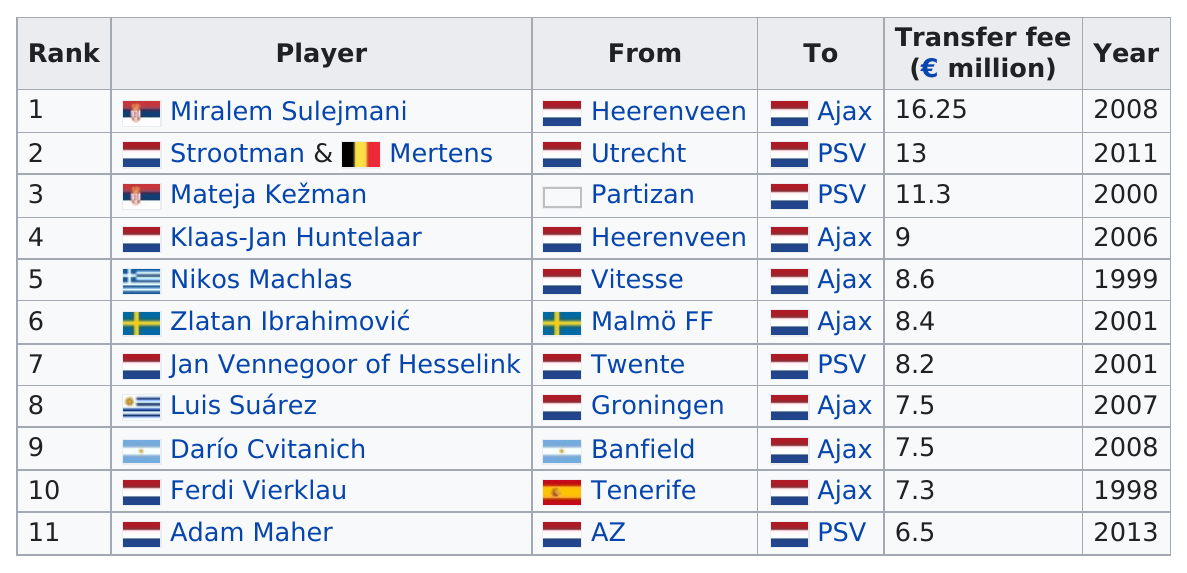Highlight a few significant elements in this photo. Seven players had a transfer fee of at least 8 million. A number of players transferred after 2010, with two specifically mentioned. Ajax has acquired the services of seven players. After the year 2000, a total of 8 players were transferred. Miralem Sulejmani, an incoming player, had the highest transfer fee among all players. 